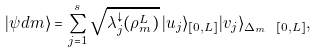<formula> <loc_0><loc_0><loc_500><loc_500>| \psi d m \rangle = \sum _ { j = 1 } ^ { s } \sqrt { \lambda _ { j } ^ { \downarrow } ( \rho _ { m } ^ { L } ) } \, | u _ { j } \rangle _ { [ 0 , L ] } | v _ { j } \rangle _ { \Delta _ { m } \ [ 0 , L ] } ,</formula> 